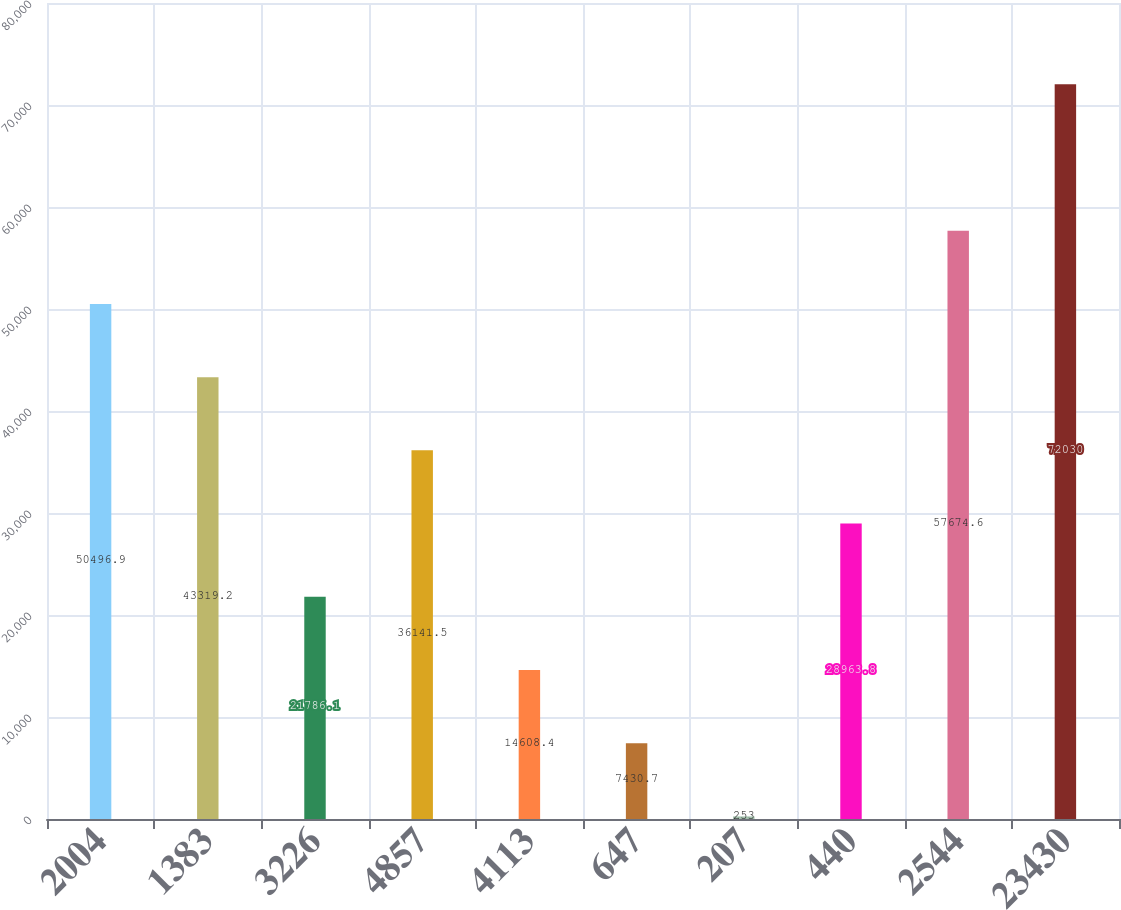Convert chart. <chart><loc_0><loc_0><loc_500><loc_500><bar_chart><fcel>2004<fcel>1383<fcel>3226<fcel>4857<fcel>4113<fcel>647<fcel>207<fcel>440<fcel>2544<fcel>23430<nl><fcel>50496.9<fcel>43319.2<fcel>21786.1<fcel>36141.5<fcel>14608.4<fcel>7430.7<fcel>253<fcel>28963.8<fcel>57674.6<fcel>72030<nl></chart> 